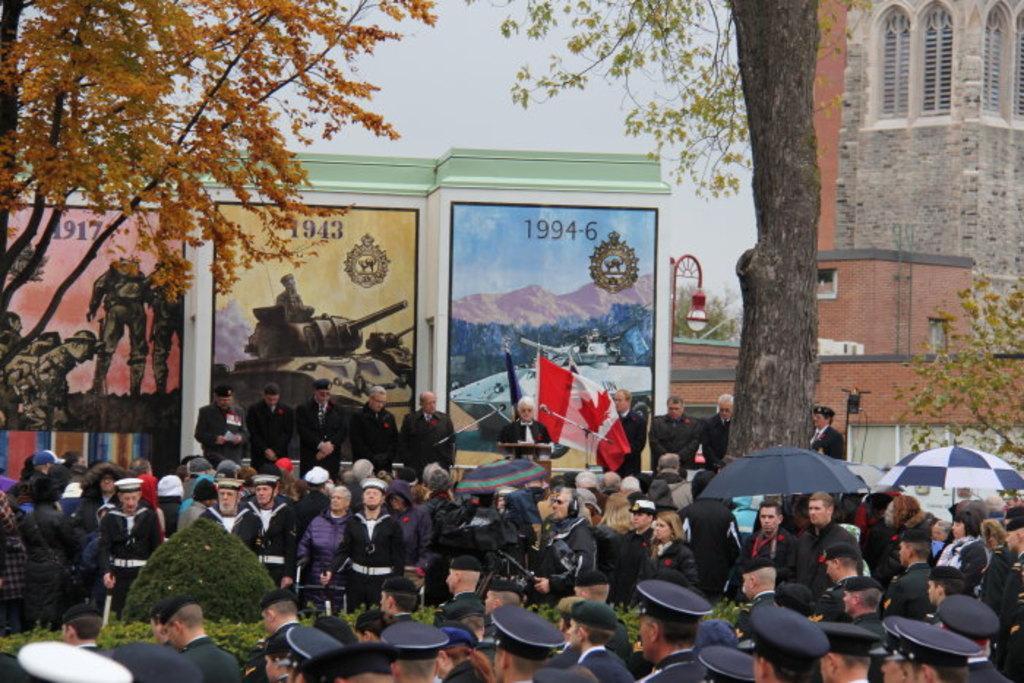In one or two sentences, can you explain what this image depicts? In the picture I can see a group of people. I can see a man standing in front of a wooden podium and looks like he is speaking on a microphone. I can see the army vehicle and army people paintings on the wall of the building. There is a trunk of a tree on the right side. 